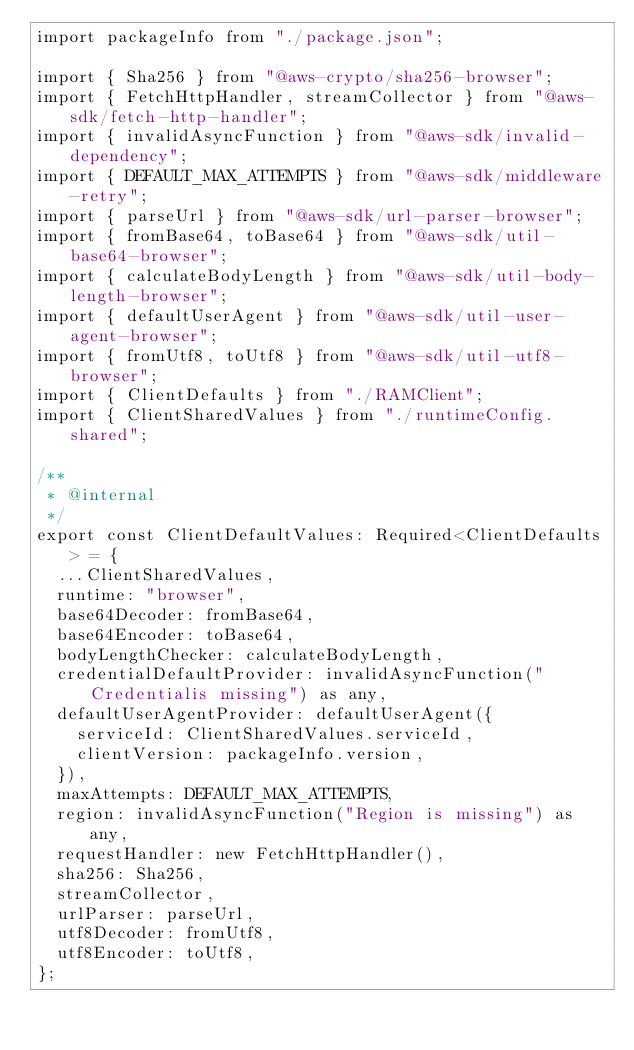Convert code to text. <code><loc_0><loc_0><loc_500><loc_500><_TypeScript_>import packageInfo from "./package.json";

import { Sha256 } from "@aws-crypto/sha256-browser";
import { FetchHttpHandler, streamCollector } from "@aws-sdk/fetch-http-handler";
import { invalidAsyncFunction } from "@aws-sdk/invalid-dependency";
import { DEFAULT_MAX_ATTEMPTS } from "@aws-sdk/middleware-retry";
import { parseUrl } from "@aws-sdk/url-parser-browser";
import { fromBase64, toBase64 } from "@aws-sdk/util-base64-browser";
import { calculateBodyLength } from "@aws-sdk/util-body-length-browser";
import { defaultUserAgent } from "@aws-sdk/util-user-agent-browser";
import { fromUtf8, toUtf8 } from "@aws-sdk/util-utf8-browser";
import { ClientDefaults } from "./RAMClient";
import { ClientSharedValues } from "./runtimeConfig.shared";

/**
 * @internal
 */
export const ClientDefaultValues: Required<ClientDefaults> = {
  ...ClientSharedValues,
  runtime: "browser",
  base64Decoder: fromBase64,
  base64Encoder: toBase64,
  bodyLengthChecker: calculateBodyLength,
  credentialDefaultProvider: invalidAsyncFunction("Credentialis missing") as any,
  defaultUserAgentProvider: defaultUserAgent({
    serviceId: ClientSharedValues.serviceId,
    clientVersion: packageInfo.version,
  }),
  maxAttempts: DEFAULT_MAX_ATTEMPTS,
  region: invalidAsyncFunction("Region is missing") as any,
  requestHandler: new FetchHttpHandler(),
  sha256: Sha256,
  streamCollector,
  urlParser: parseUrl,
  utf8Decoder: fromUtf8,
  utf8Encoder: toUtf8,
};
</code> 